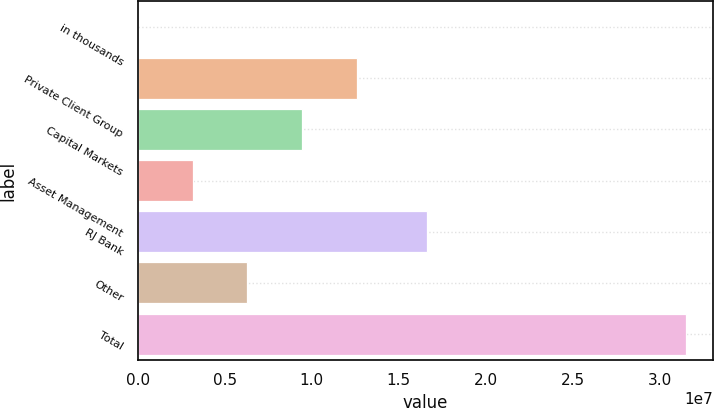Convert chart to OTSL. <chart><loc_0><loc_0><loc_500><loc_500><bar_chart><fcel>in thousands<fcel>Private Client Group<fcel>Capital Markets<fcel>Asset Management<fcel>RJ Bank<fcel>Other<fcel>Total<nl><fcel>2016<fcel>1.2596e+07<fcel>9.4475e+06<fcel>3.15051e+06<fcel>1.66134e+07<fcel>6.29901e+06<fcel>3.1487e+07<nl></chart> 